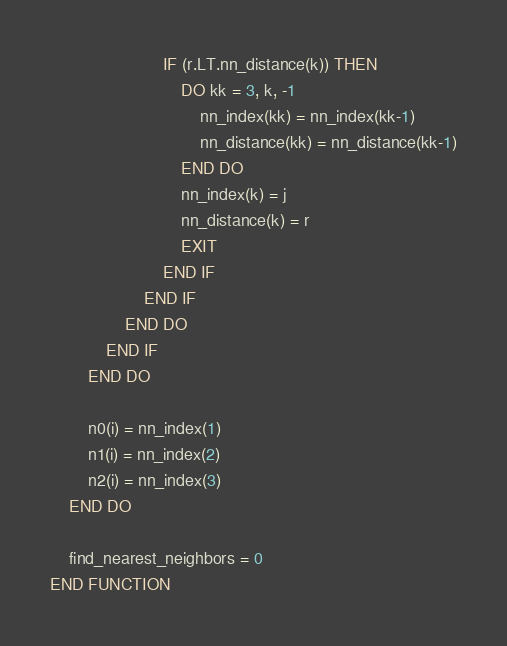<code> <loc_0><loc_0><loc_500><loc_500><_FORTRAN_>                        IF (r.LT.nn_distance(k)) THEN
                            DO kk = 3, k, -1
                                nn_index(kk) = nn_index(kk-1)
                                nn_distance(kk) = nn_distance(kk-1)
                            END DO
                            nn_index(k) = j
                            nn_distance(k) = r
                            EXIT
                        END IF
                    END IF
                END DO
            END IF
        END DO
        
        n0(i) = nn_index(1)
        n1(i) = nn_index(2)
        n2(i) = nn_index(3)
    END DO
    
    find_nearest_neighbors = 0
END FUNCTION
</code> 